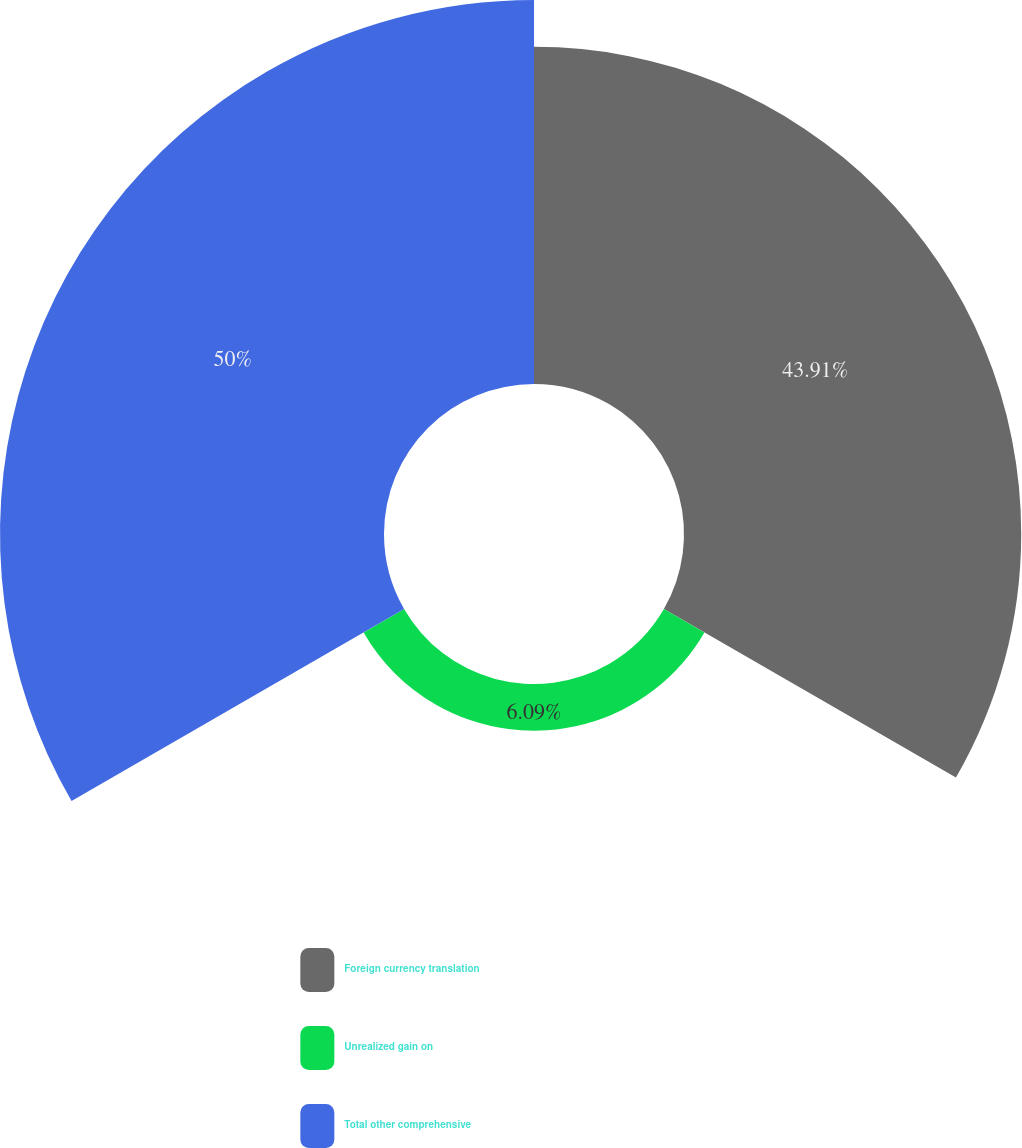<chart> <loc_0><loc_0><loc_500><loc_500><pie_chart><fcel>Foreign currency translation<fcel>Unrealized gain on<fcel>Total other comprehensive<nl><fcel>43.91%<fcel>6.09%<fcel>50.0%<nl></chart> 